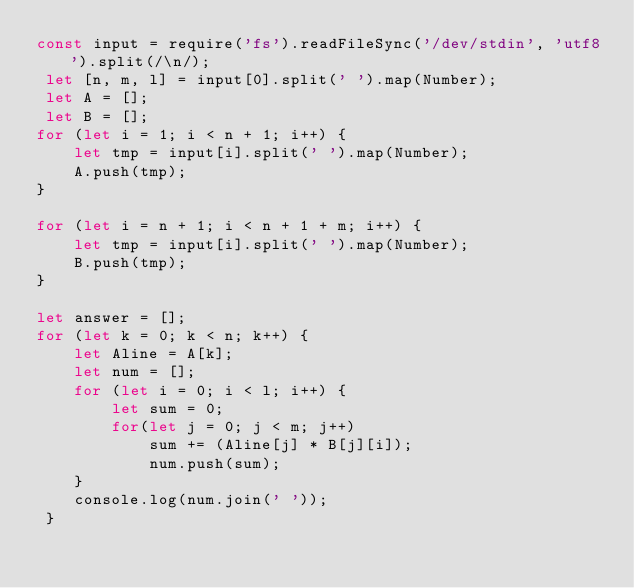Convert code to text. <code><loc_0><loc_0><loc_500><loc_500><_JavaScript_>const input = require('fs').readFileSync('/dev/stdin', 'utf8').split(/\n/);
 let [n, m, l] = input[0].split(' ').map(Number);
 let A = [];
 let B = [];
for (let i = 1; i < n + 1; i++) {
    let tmp = input[i].split(' ').map(Number);
    A.push(tmp);
}

for (let i = n + 1; i < n + 1 + m; i++) {
    let tmp = input[i].split(' ').map(Number);
    B.push(tmp);
}

let answer = [];
for (let k = 0; k < n; k++) {
    let Aline = A[k];
    let num = [];
    for (let i = 0; i < l; i++) {
        let sum = 0;
        for(let j = 0; j < m; j++) 
            sum += (Aline[j] * B[j][i]);
            num.push(sum);
    }
    console.log(num.join(' '));
 }
 

</code> 